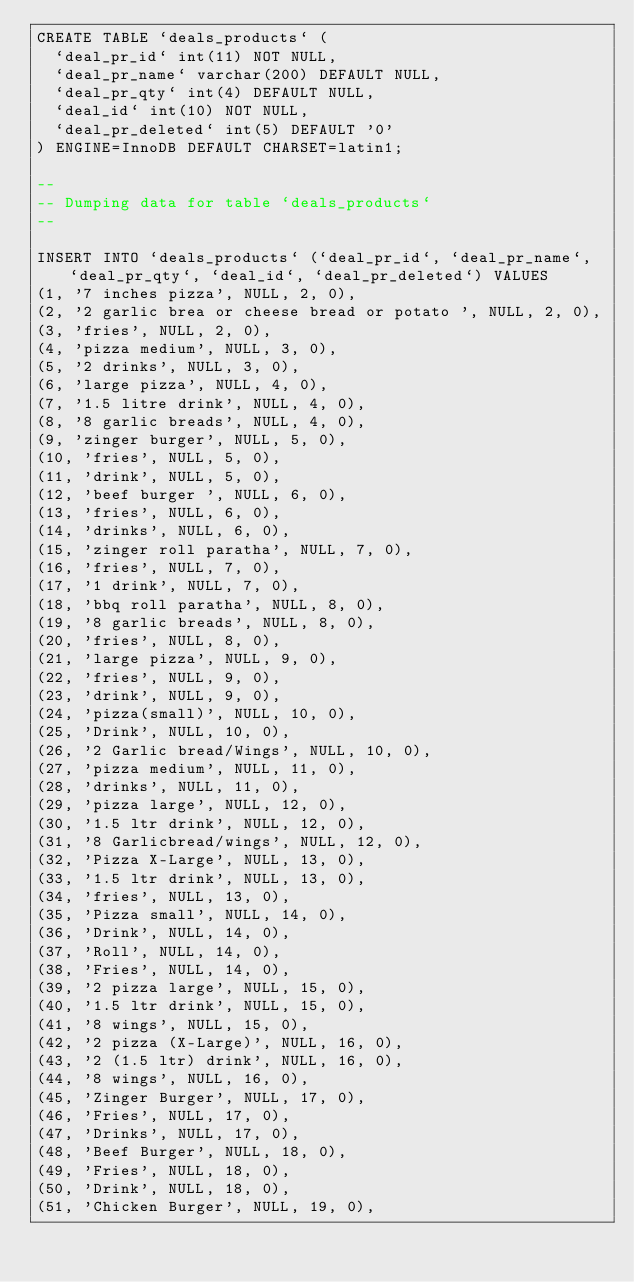<code> <loc_0><loc_0><loc_500><loc_500><_SQL_>CREATE TABLE `deals_products` (
  `deal_pr_id` int(11) NOT NULL,
  `deal_pr_name` varchar(200) DEFAULT NULL,
  `deal_pr_qty` int(4) DEFAULT NULL,
  `deal_id` int(10) NOT NULL,
  `deal_pr_deleted` int(5) DEFAULT '0'
) ENGINE=InnoDB DEFAULT CHARSET=latin1;

--
-- Dumping data for table `deals_products`
--

INSERT INTO `deals_products` (`deal_pr_id`, `deal_pr_name`, `deal_pr_qty`, `deal_id`, `deal_pr_deleted`) VALUES
(1, '7 inches pizza', NULL, 2, 0),
(2, '2 garlic brea or cheese bread or potato ', NULL, 2, 0),
(3, 'fries', NULL, 2, 0),
(4, 'pizza medium', NULL, 3, 0),
(5, '2 drinks', NULL, 3, 0),
(6, 'large pizza', NULL, 4, 0),
(7, '1.5 litre drink', NULL, 4, 0),
(8, '8 garlic breads', NULL, 4, 0),
(9, 'zinger burger', NULL, 5, 0),
(10, 'fries', NULL, 5, 0),
(11, 'drink', NULL, 5, 0),
(12, 'beef burger ', NULL, 6, 0),
(13, 'fries', NULL, 6, 0),
(14, 'drinks', NULL, 6, 0),
(15, 'zinger roll paratha', NULL, 7, 0),
(16, 'fries', NULL, 7, 0),
(17, '1 drink', NULL, 7, 0),
(18, 'bbq roll paratha', NULL, 8, 0),
(19, '8 garlic breads', NULL, 8, 0),
(20, 'fries', NULL, 8, 0),
(21, 'large pizza', NULL, 9, 0),
(22, 'fries', NULL, 9, 0),
(23, 'drink', NULL, 9, 0),
(24, 'pizza(small)', NULL, 10, 0),
(25, 'Drink', NULL, 10, 0),
(26, '2 Garlic bread/Wings', NULL, 10, 0),
(27, 'pizza medium', NULL, 11, 0),
(28, 'drinks', NULL, 11, 0),
(29, 'pizza large', NULL, 12, 0),
(30, '1.5 ltr drink', NULL, 12, 0),
(31, '8 Garlicbread/wings', NULL, 12, 0),
(32, 'Pizza X-Large', NULL, 13, 0),
(33, '1.5 ltr drink', NULL, 13, 0),
(34, 'fries', NULL, 13, 0),
(35, 'Pizza small', NULL, 14, 0),
(36, 'Drink', NULL, 14, 0),
(37, 'Roll', NULL, 14, 0),
(38, 'Fries', NULL, 14, 0),
(39, '2 pizza large', NULL, 15, 0),
(40, '1.5 ltr drink', NULL, 15, 0),
(41, '8 wings', NULL, 15, 0),
(42, '2 pizza (X-Large)', NULL, 16, 0),
(43, '2 (1.5 ltr) drink', NULL, 16, 0),
(44, '8 wings', NULL, 16, 0),
(45, 'Zinger Burger', NULL, 17, 0),
(46, 'Fries', NULL, 17, 0),
(47, 'Drinks', NULL, 17, 0),
(48, 'Beef Burger', NULL, 18, 0),
(49, 'Fries', NULL, 18, 0),
(50, 'Drink', NULL, 18, 0),
(51, 'Chicken Burger', NULL, 19, 0),</code> 